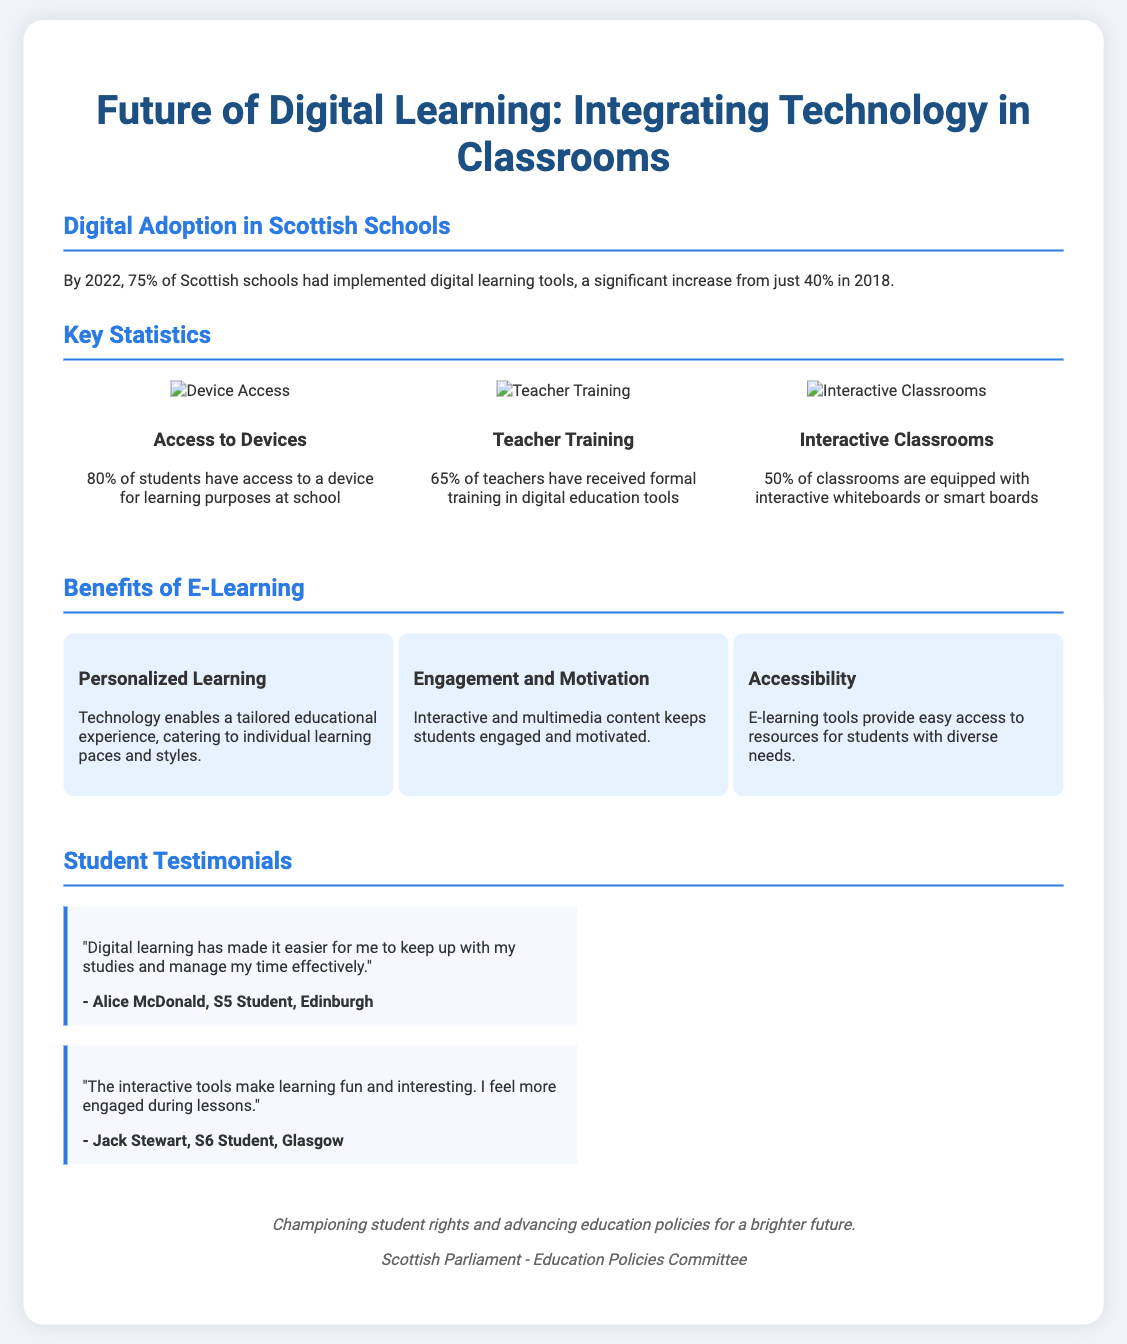What percentage of Scottish schools implemented digital learning tools by 2022? The document states that by 2022, 75% of Scottish schools had implemented digital learning tools.
Answer: 75% What was the percentage increase of digital learning tool adoption from 2018 to 2022? The adoption increased from 40% in 2018 to 75% in 2022, which is a 35% increase.
Answer: 35% What percentage of students have access to a device for learning at school? The document specifies that 80% of students have access to a device for learning purposes at school.
Answer: 80% What is one benefit of e-learning mentioned in the poster? The benefits section lists personalized learning, engagement and motivation, and accessibility as benefits.
Answer: Personalized Learning How many classrooms are equipped with interactive whiteboards or smart boards? The document states that 50% of classrooms are equipped with interactive whiteboards or smart boards.
Answer: 50% Which student from Edinburgh provided a testimonial about digital learning? The testimonial section mentions Alice McDonald, a S5 student from Edinburgh.
Answer: Alice McDonald What is the color scheme primarily used in the poster design? The poster uses a combination of white, light blue, and dark blue for a modern look.
Answer: White and blue What organization is highlighted in the footer as championing student rights? The footer mentions the Scottish Parliament - Education Policies Committee as the organization championing student rights.
Answer: Scottish Parliament - Education Policies Committee 